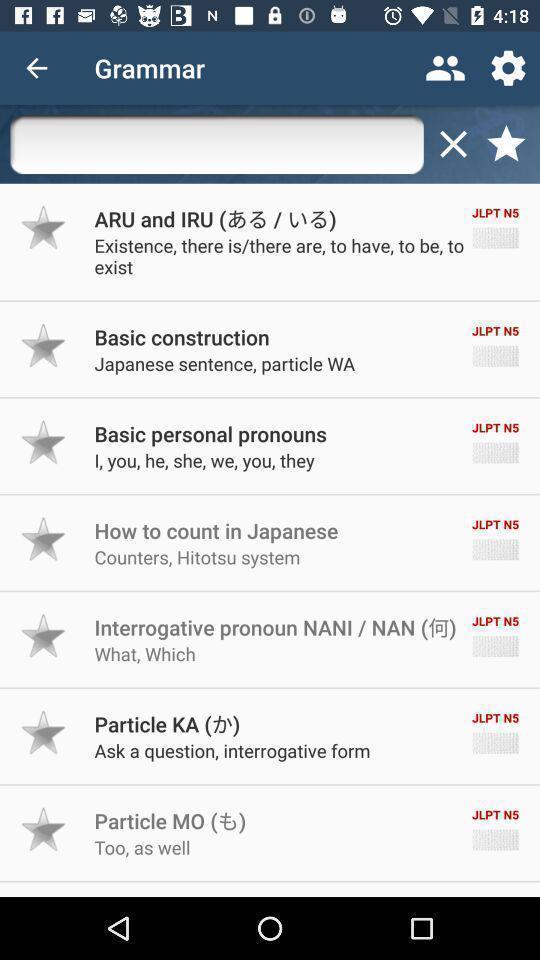Tell me what you see in this picture. Screen shows list of options in a learning app. 